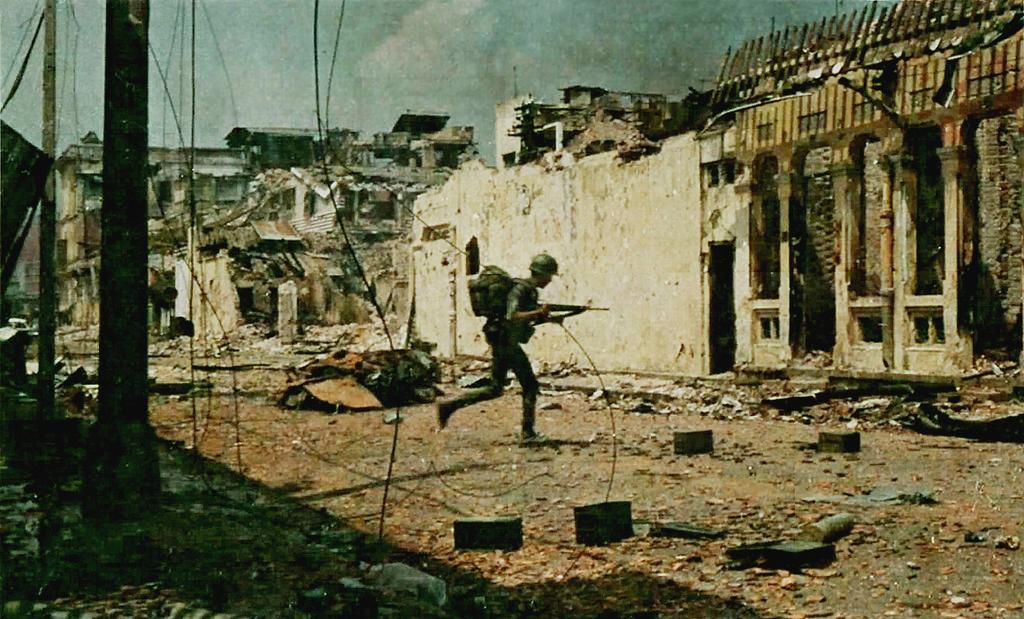Can you describe this image briefly? There is a person, wearing helmet and bag, holding a gun and running on the ground. On the left side, there are two poles on the ground and there are cables. In front of him, there are buildings destroyed. In the background, there are clouds in the sky. 